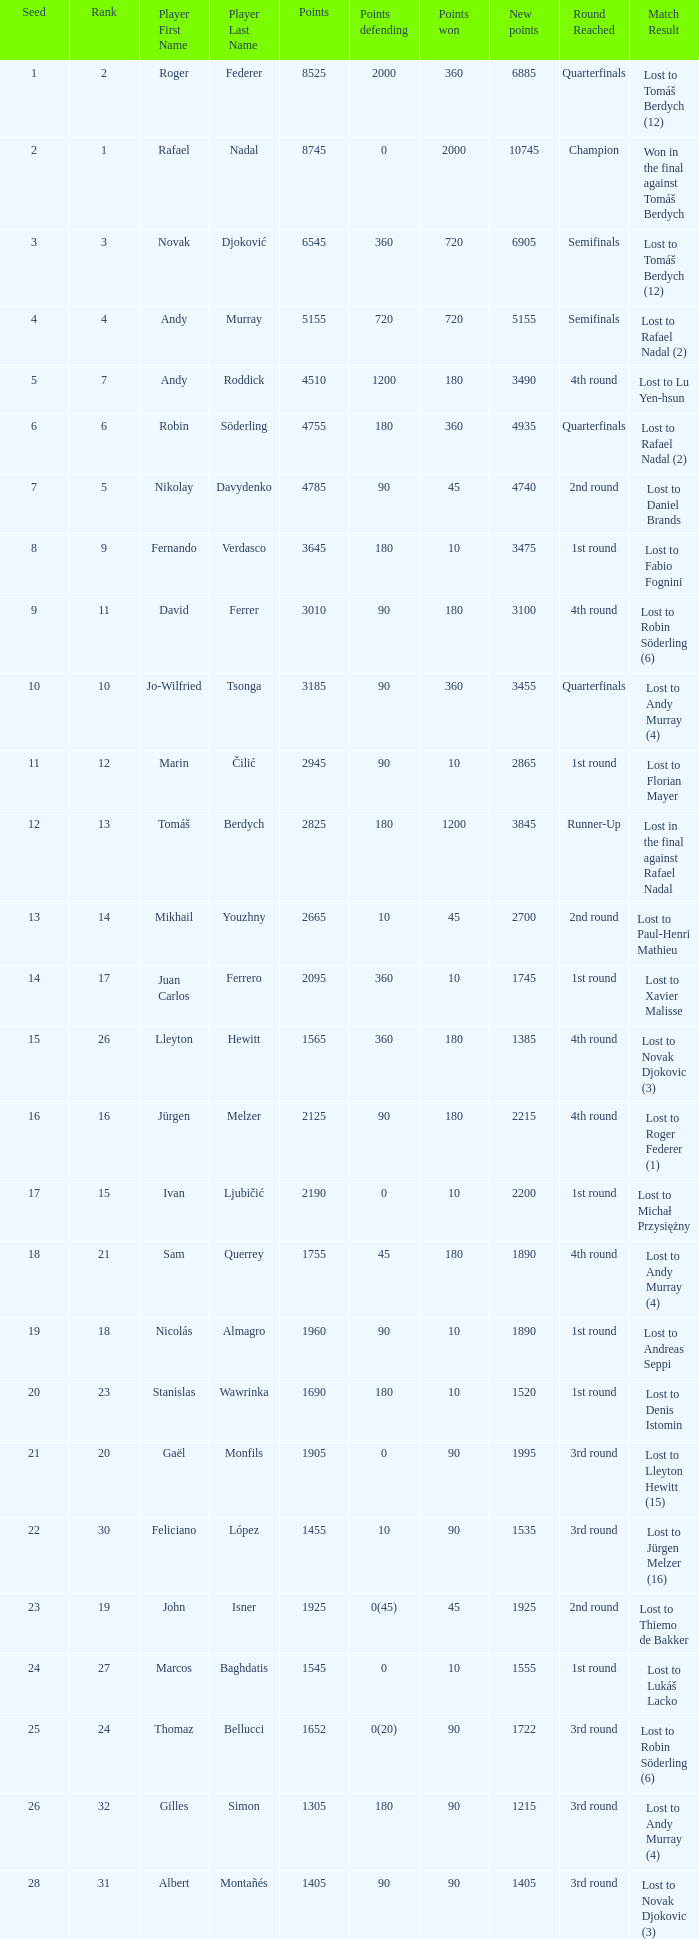Name the number of points defending for 1075 1.0. 